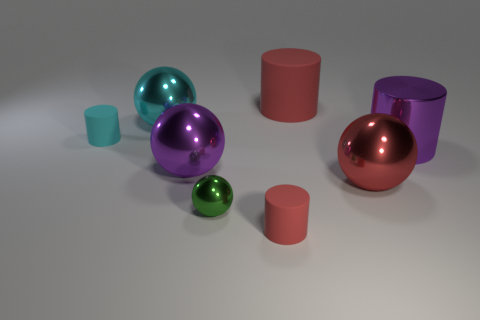Add 1 tiny cylinders. How many objects exist? 9 Subtract all cyan rubber cylinders. How many cylinders are left? 3 Subtract 2 cylinders. How many cylinders are left? 2 Subtract all green spheres. Subtract all brown cylinders. How many spheres are left? 3 Subtract all red cubes. How many blue balls are left? 0 Subtract all big metal objects. Subtract all yellow things. How many objects are left? 4 Add 5 purple things. How many purple things are left? 7 Add 5 small purple shiny cylinders. How many small purple shiny cylinders exist? 5 Subtract all purple cylinders. How many cylinders are left? 3 Subtract 0 brown cubes. How many objects are left? 8 